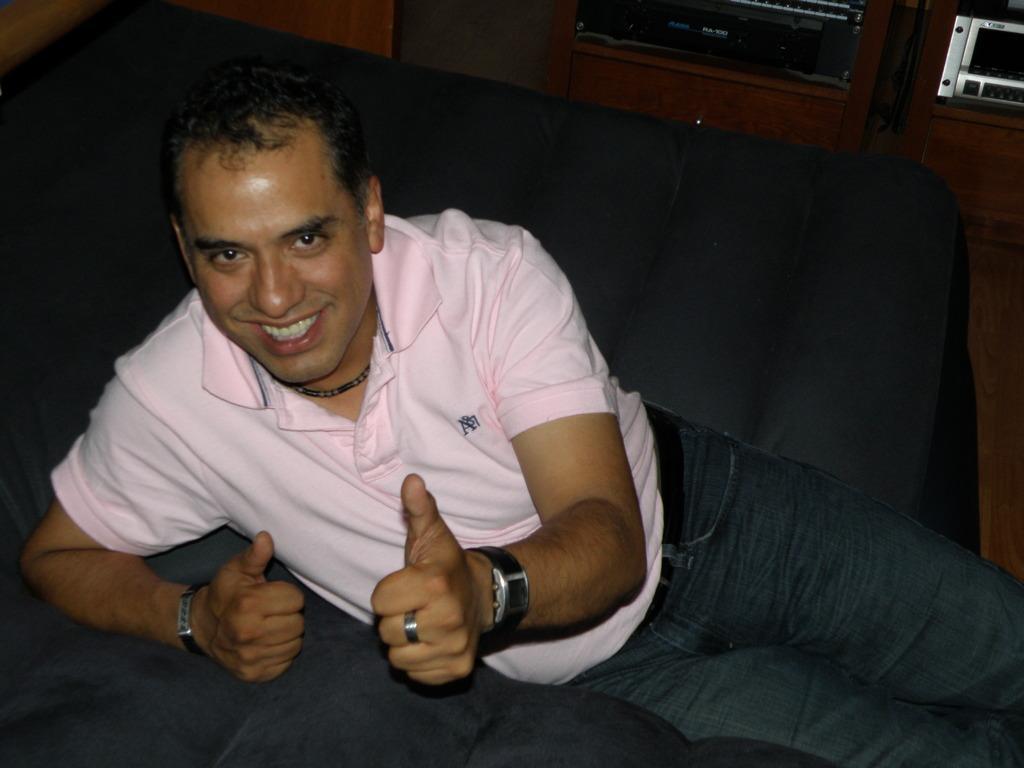In one or two sentences, can you explain what this image depicts? In this image in the center there is one person who is smiling, and at the bottom there is a couch. In the background there are some cupboards, microwave oven and at the bottom there is a floor. 